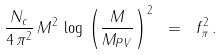Convert formula to latex. <formula><loc_0><loc_0><loc_500><loc_500>\frac { N _ { c } } { 4 \, \pi ^ { 2 } } \, M ^ { 2 } \, \log \, { \left ( \frac { M } { M _ { P V } } \right ) } ^ { 2 } \ = \ f _ { \pi } ^ { 2 } \, .</formula> 